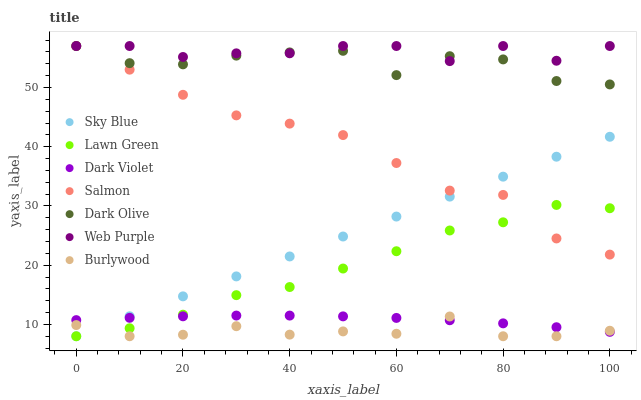Does Burlywood have the minimum area under the curve?
Answer yes or no. Yes. Does Web Purple have the maximum area under the curve?
Answer yes or no. Yes. Does Dark Olive have the minimum area under the curve?
Answer yes or no. No. Does Dark Olive have the maximum area under the curve?
Answer yes or no. No. Is Sky Blue the smoothest?
Answer yes or no. Yes. Is Dark Olive the roughest?
Answer yes or no. Yes. Is Burlywood the smoothest?
Answer yes or no. No. Is Burlywood the roughest?
Answer yes or no. No. Does Lawn Green have the lowest value?
Answer yes or no. Yes. Does Dark Olive have the lowest value?
Answer yes or no. No. Does Web Purple have the highest value?
Answer yes or no. Yes. Does Burlywood have the highest value?
Answer yes or no. No. Is Burlywood less than Dark Olive?
Answer yes or no. Yes. Is Web Purple greater than Sky Blue?
Answer yes or no. Yes. Does Sky Blue intersect Salmon?
Answer yes or no. Yes. Is Sky Blue less than Salmon?
Answer yes or no. No. Is Sky Blue greater than Salmon?
Answer yes or no. No. Does Burlywood intersect Dark Olive?
Answer yes or no. No. 